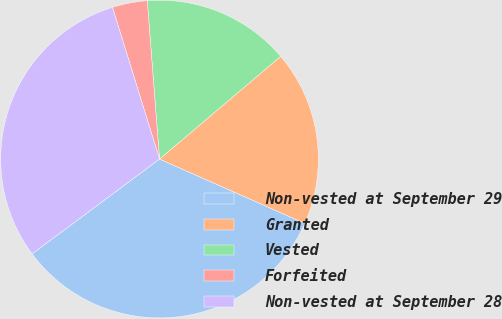<chart> <loc_0><loc_0><loc_500><loc_500><pie_chart><fcel>Non-vested at September 29<fcel>Granted<fcel>Vested<fcel>Forfeited<fcel>Non-vested at September 28<nl><fcel>33.19%<fcel>17.83%<fcel>15.04%<fcel>3.56%<fcel>30.4%<nl></chart> 